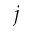<formula> <loc_0><loc_0><loc_500><loc_500>j</formula> 